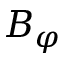<formula> <loc_0><loc_0><loc_500><loc_500>B _ { \varphi }</formula> 